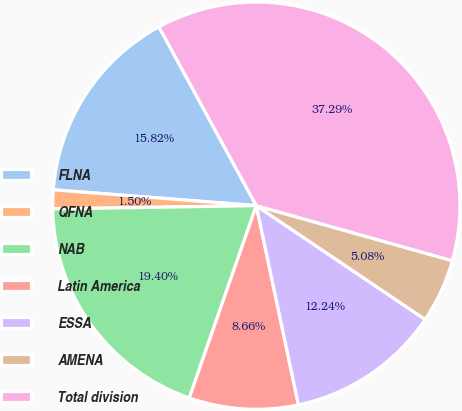<chart> <loc_0><loc_0><loc_500><loc_500><pie_chart><fcel>FLNA<fcel>QFNA<fcel>NAB<fcel>Latin America<fcel>ESSA<fcel>AMENA<fcel>Total division<nl><fcel>15.82%<fcel>1.5%<fcel>19.4%<fcel>8.66%<fcel>12.24%<fcel>5.08%<fcel>37.29%<nl></chart> 